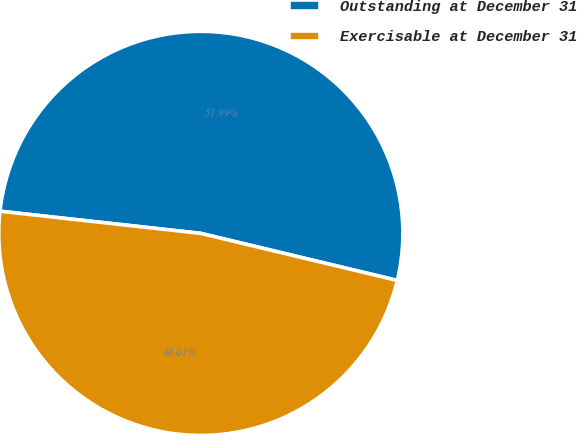Convert chart. <chart><loc_0><loc_0><loc_500><loc_500><pie_chart><fcel>Outstanding at December 31<fcel>Exercisable at December 31<nl><fcel>51.99%<fcel>48.01%<nl></chart> 